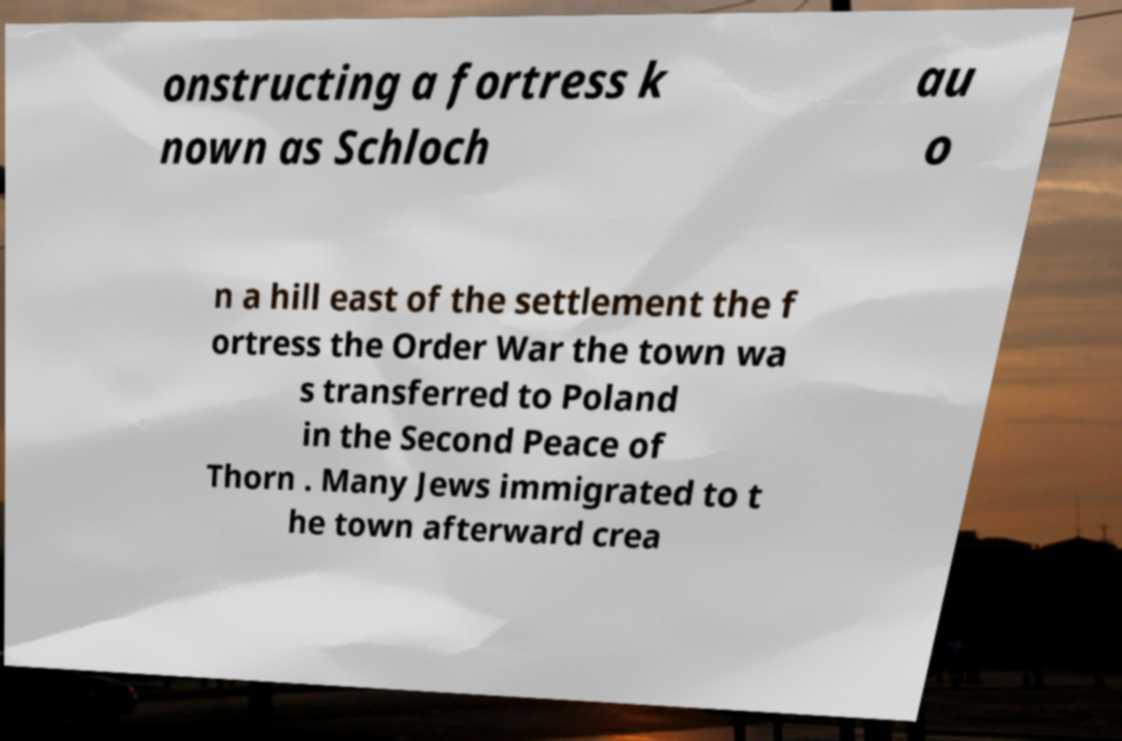Can you accurately transcribe the text from the provided image for me? onstructing a fortress k nown as Schloch au o n a hill east of the settlement the f ortress the Order War the town wa s transferred to Poland in the Second Peace of Thorn . Many Jews immigrated to t he town afterward crea 